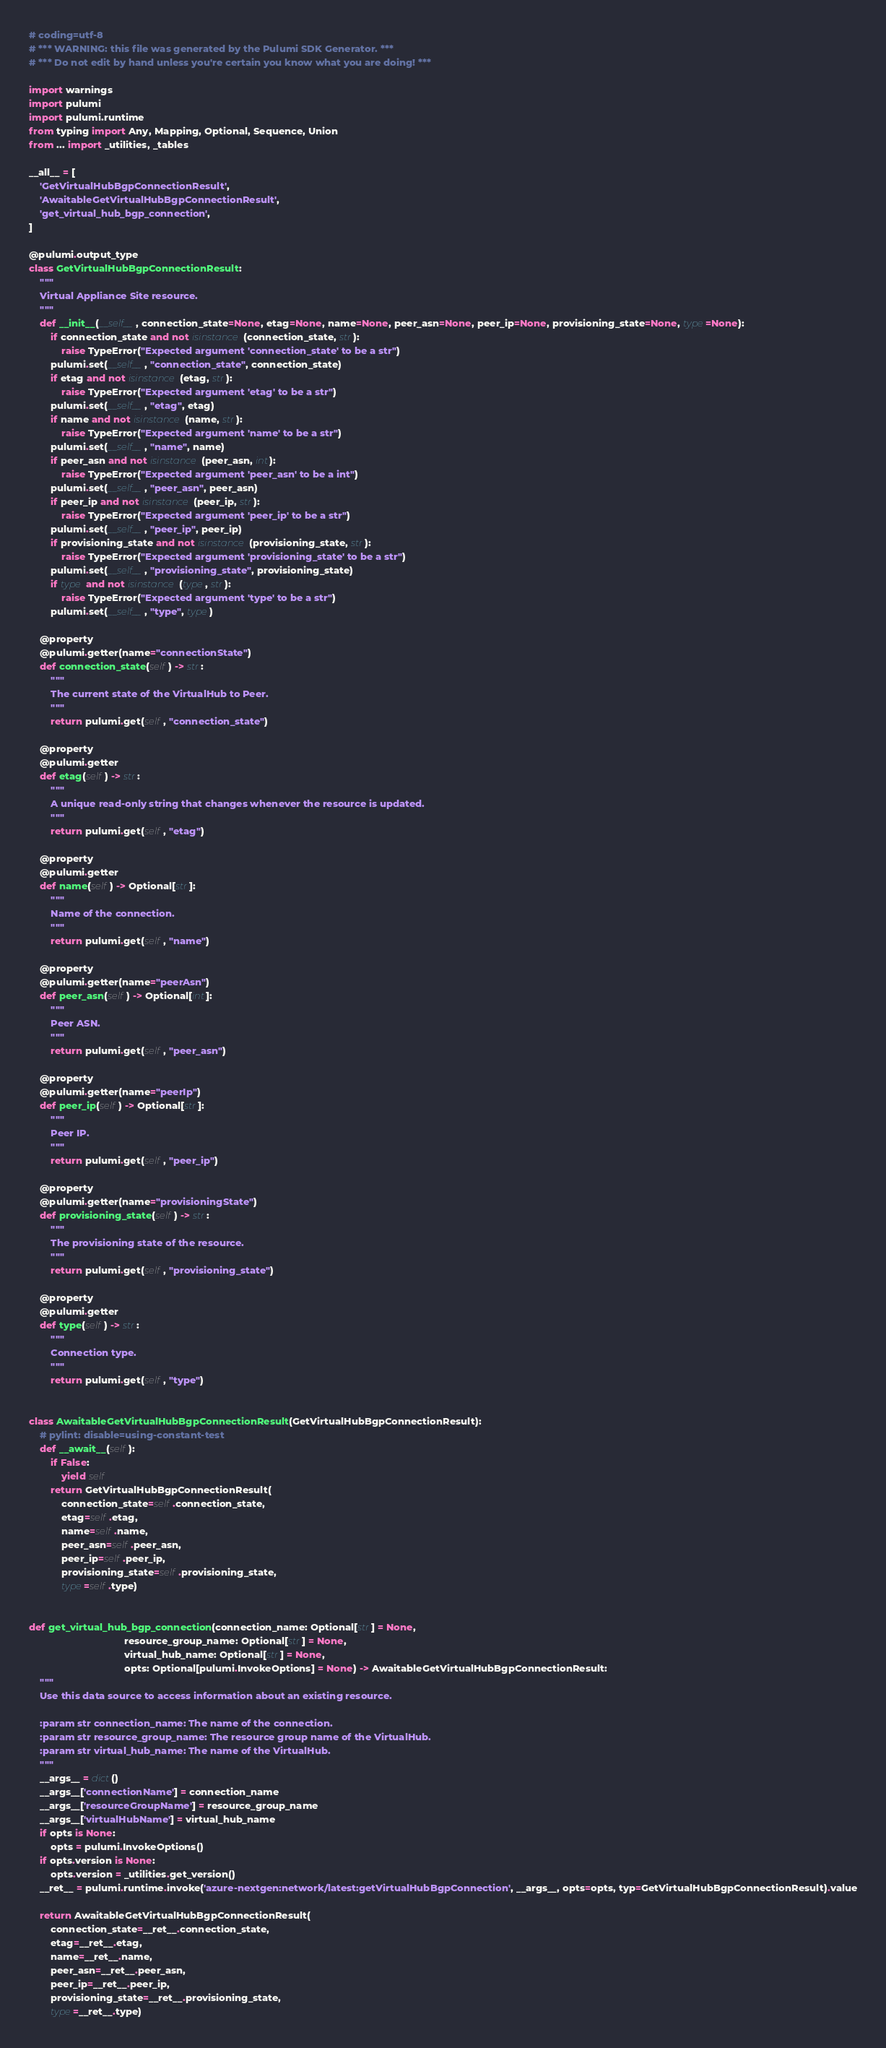Convert code to text. <code><loc_0><loc_0><loc_500><loc_500><_Python_># coding=utf-8
# *** WARNING: this file was generated by the Pulumi SDK Generator. ***
# *** Do not edit by hand unless you're certain you know what you are doing! ***

import warnings
import pulumi
import pulumi.runtime
from typing import Any, Mapping, Optional, Sequence, Union
from ... import _utilities, _tables

__all__ = [
    'GetVirtualHubBgpConnectionResult',
    'AwaitableGetVirtualHubBgpConnectionResult',
    'get_virtual_hub_bgp_connection',
]

@pulumi.output_type
class GetVirtualHubBgpConnectionResult:
    """
    Virtual Appliance Site resource.
    """
    def __init__(__self__, connection_state=None, etag=None, name=None, peer_asn=None, peer_ip=None, provisioning_state=None, type=None):
        if connection_state and not isinstance(connection_state, str):
            raise TypeError("Expected argument 'connection_state' to be a str")
        pulumi.set(__self__, "connection_state", connection_state)
        if etag and not isinstance(etag, str):
            raise TypeError("Expected argument 'etag' to be a str")
        pulumi.set(__self__, "etag", etag)
        if name and not isinstance(name, str):
            raise TypeError("Expected argument 'name' to be a str")
        pulumi.set(__self__, "name", name)
        if peer_asn and not isinstance(peer_asn, int):
            raise TypeError("Expected argument 'peer_asn' to be a int")
        pulumi.set(__self__, "peer_asn", peer_asn)
        if peer_ip and not isinstance(peer_ip, str):
            raise TypeError("Expected argument 'peer_ip' to be a str")
        pulumi.set(__self__, "peer_ip", peer_ip)
        if provisioning_state and not isinstance(provisioning_state, str):
            raise TypeError("Expected argument 'provisioning_state' to be a str")
        pulumi.set(__self__, "provisioning_state", provisioning_state)
        if type and not isinstance(type, str):
            raise TypeError("Expected argument 'type' to be a str")
        pulumi.set(__self__, "type", type)

    @property
    @pulumi.getter(name="connectionState")
    def connection_state(self) -> str:
        """
        The current state of the VirtualHub to Peer.
        """
        return pulumi.get(self, "connection_state")

    @property
    @pulumi.getter
    def etag(self) -> str:
        """
        A unique read-only string that changes whenever the resource is updated.
        """
        return pulumi.get(self, "etag")

    @property
    @pulumi.getter
    def name(self) -> Optional[str]:
        """
        Name of the connection.
        """
        return pulumi.get(self, "name")

    @property
    @pulumi.getter(name="peerAsn")
    def peer_asn(self) -> Optional[int]:
        """
        Peer ASN.
        """
        return pulumi.get(self, "peer_asn")

    @property
    @pulumi.getter(name="peerIp")
    def peer_ip(self) -> Optional[str]:
        """
        Peer IP.
        """
        return pulumi.get(self, "peer_ip")

    @property
    @pulumi.getter(name="provisioningState")
    def provisioning_state(self) -> str:
        """
        The provisioning state of the resource.
        """
        return pulumi.get(self, "provisioning_state")

    @property
    @pulumi.getter
    def type(self) -> str:
        """
        Connection type.
        """
        return pulumi.get(self, "type")


class AwaitableGetVirtualHubBgpConnectionResult(GetVirtualHubBgpConnectionResult):
    # pylint: disable=using-constant-test
    def __await__(self):
        if False:
            yield self
        return GetVirtualHubBgpConnectionResult(
            connection_state=self.connection_state,
            etag=self.etag,
            name=self.name,
            peer_asn=self.peer_asn,
            peer_ip=self.peer_ip,
            provisioning_state=self.provisioning_state,
            type=self.type)


def get_virtual_hub_bgp_connection(connection_name: Optional[str] = None,
                                   resource_group_name: Optional[str] = None,
                                   virtual_hub_name: Optional[str] = None,
                                   opts: Optional[pulumi.InvokeOptions] = None) -> AwaitableGetVirtualHubBgpConnectionResult:
    """
    Use this data source to access information about an existing resource.

    :param str connection_name: The name of the connection.
    :param str resource_group_name: The resource group name of the VirtualHub.
    :param str virtual_hub_name: The name of the VirtualHub.
    """
    __args__ = dict()
    __args__['connectionName'] = connection_name
    __args__['resourceGroupName'] = resource_group_name
    __args__['virtualHubName'] = virtual_hub_name
    if opts is None:
        opts = pulumi.InvokeOptions()
    if opts.version is None:
        opts.version = _utilities.get_version()
    __ret__ = pulumi.runtime.invoke('azure-nextgen:network/latest:getVirtualHubBgpConnection', __args__, opts=opts, typ=GetVirtualHubBgpConnectionResult).value

    return AwaitableGetVirtualHubBgpConnectionResult(
        connection_state=__ret__.connection_state,
        etag=__ret__.etag,
        name=__ret__.name,
        peer_asn=__ret__.peer_asn,
        peer_ip=__ret__.peer_ip,
        provisioning_state=__ret__.provisioning_state,
        type=__ret__.type)
</code> 